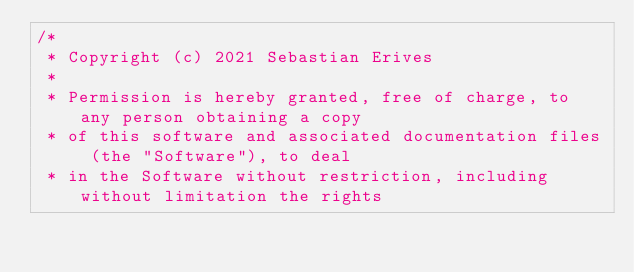Convert code to text. <code><loc_0><loc_0><loc_500><loc_500><_Kotlin_>/*
 * Copyright (c) 2021 Sebastian Erives
 *
 * Permission is hereby granted, free of charge, to any person obtaining a copy
 * of this software and associated documentation files (the "Software"), to deal
 * in the Software without restriction, including without limitation the rights</code> 